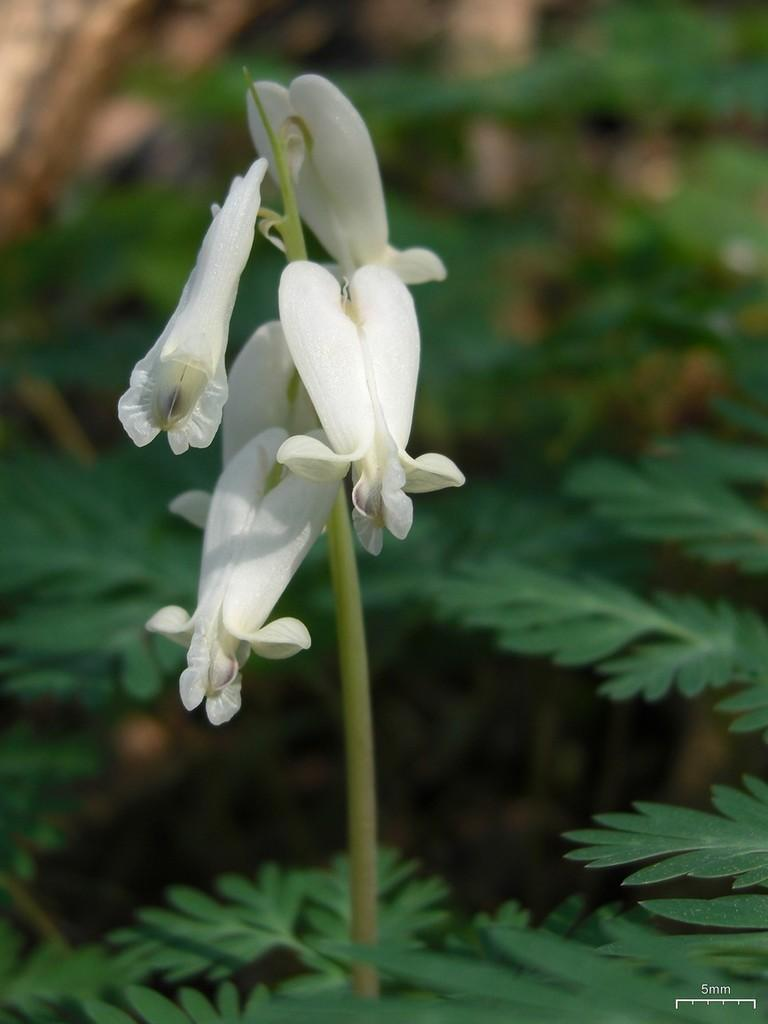What type of flowers can be seen on the plant in the image? There are white flowers on the plant in the image. Can you describe the color of the flowers? The flowers are white. What is the main subject of the image? The main subject of the image is a plant with white flowers. How many goats are grazing near the plant in the image? There are no goats present in the image; it only features a plant with white flowers. What type of utensil can be seen in the image? There is no utensil, such as a fork, present in the image. 